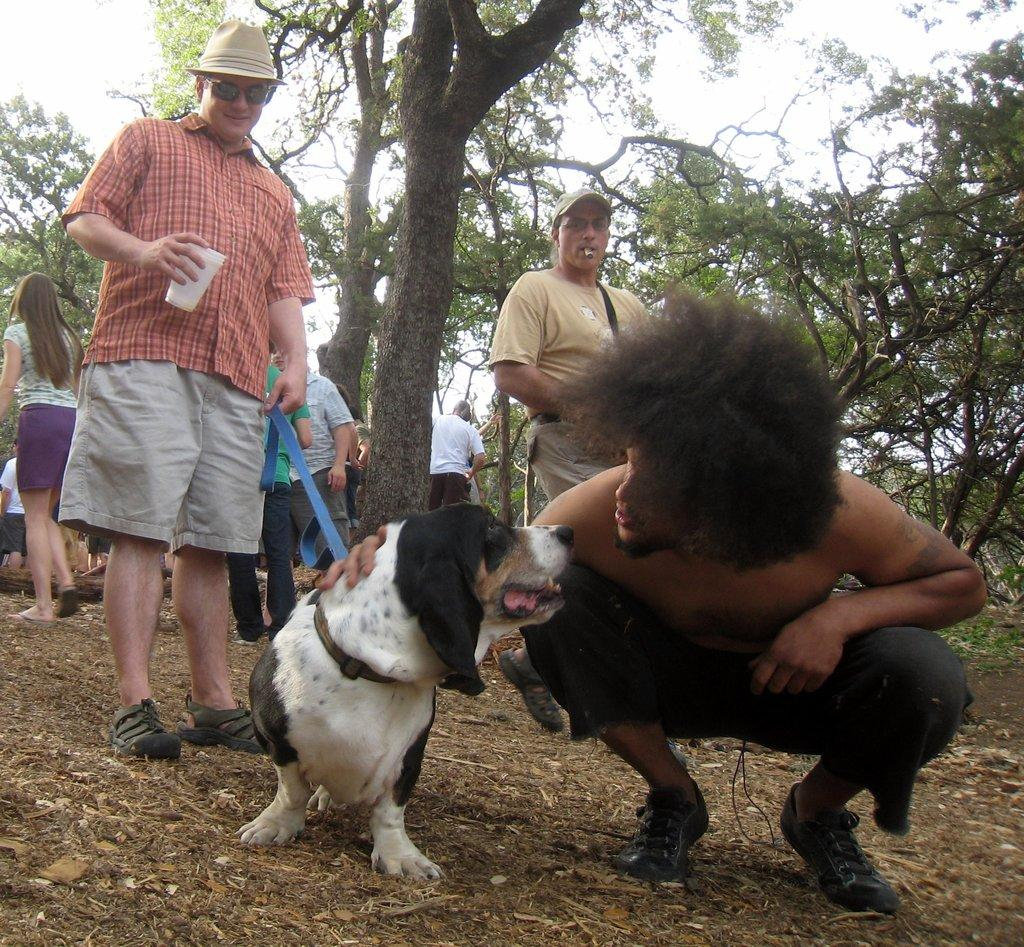What can be seen in the background of the image? There is a sky in the image. What type of natural element is present in the image? There is a tree in the image. Who or what else is present in the image? There are people and a dog in the image. How many goldfish are swimming in the sky in the image? There are no goldfish present in the image; the sky is visible in the background. What type of vessel is being used by the people in the image? There is no vessel present in the image; the people are on the ground with a dog. 